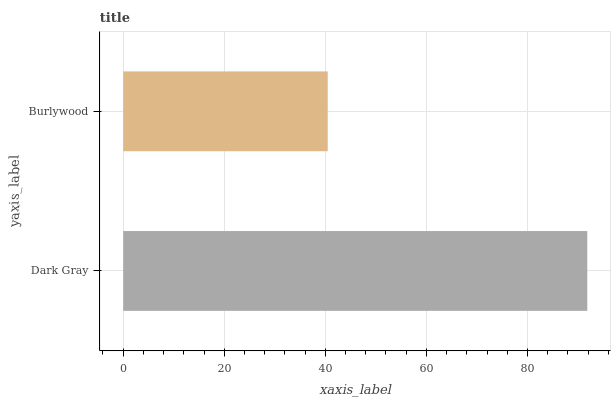Is Burlywood the minimum?
Answer yes or no. Yes. Is Dark Gray the maximum?
Answer yes or no. Yes. Is Burlywood the maximum?
Answer yes or no. No. Is Dark Gray greater than Burlywood?
Answer yes or no. Yes. Is Burlywood less than Dark Gray?
Answer yes or no. Yes. Is Burlywood greater than Dark Gray?
Answer yes or no. No. Is Dark Gray less than Burlywood?
Answer yes or no. No. Is Dark Gray the high median?
Answer yes or no. Yes. Is Burlywood the low median?
Answer yes or no. Yes. Is Burlywood the high median?
Answer yes or no. No. Is Dark Gray the low median?
Answer yes or no. No. 